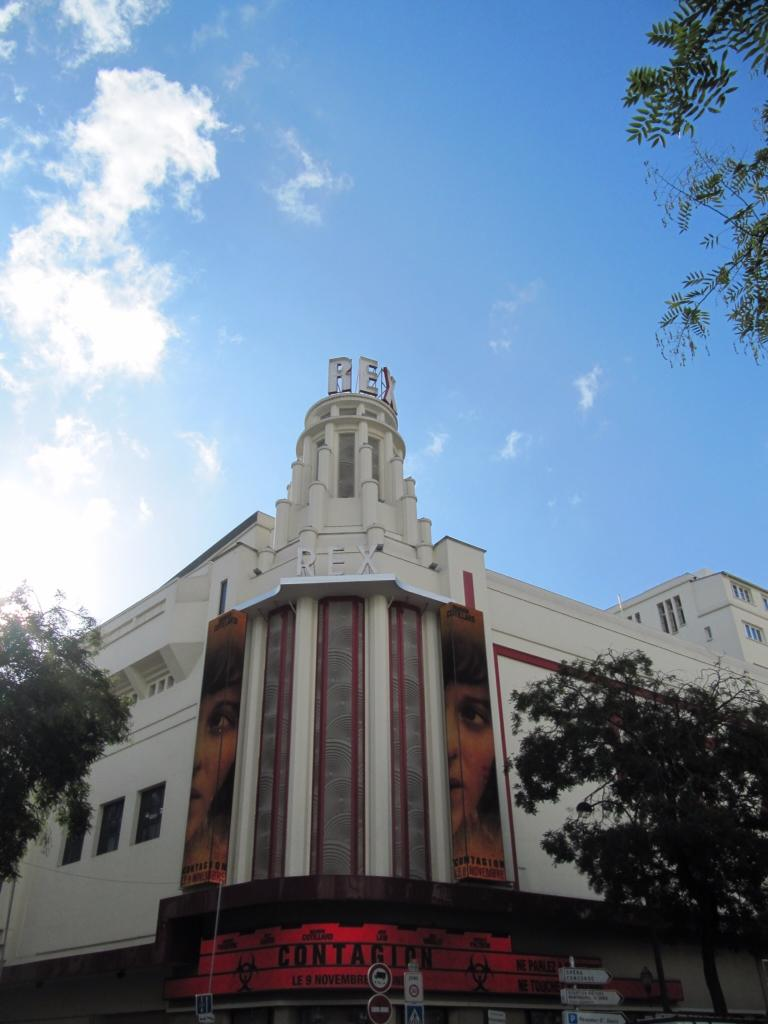<image>
Share a concise interpretation of the image provided. The Rex Theatre advertising Contagion on 9 November 